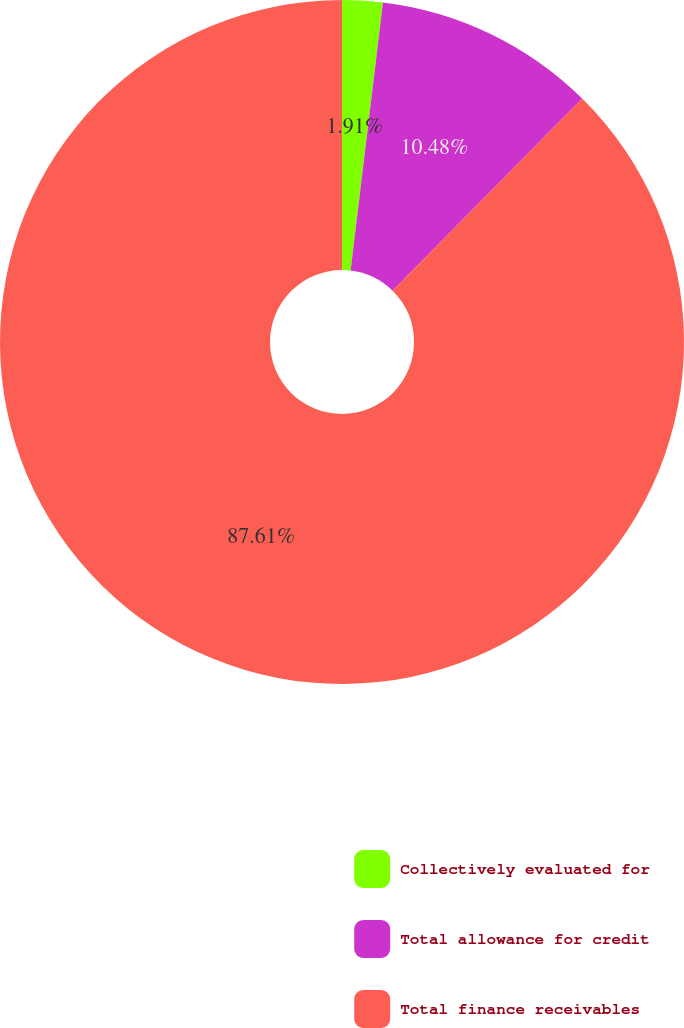Convert chart to OTSL. <chart><loc_0><loc_0><loc_500><loc_500><pie_chart><fcel>Collectively evaluated for<fcel>Total allowance for credit<fcel>Total finance receivables<nl><fcel>1.91%<fcel>10.48%<fcel>87.62%<nl></chart> 